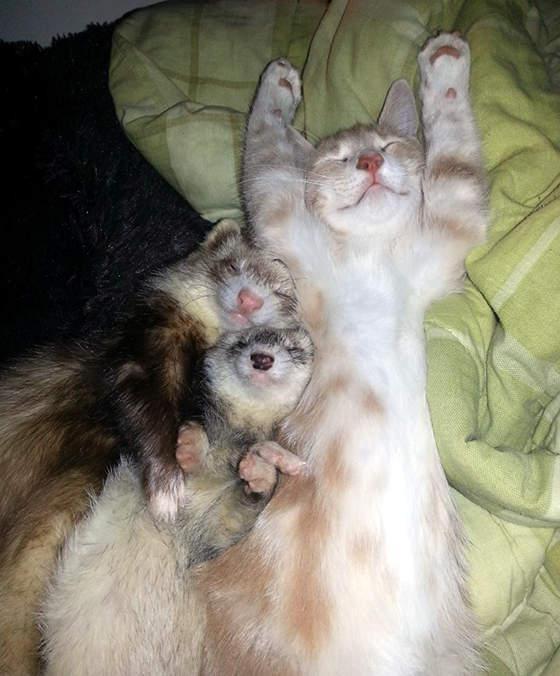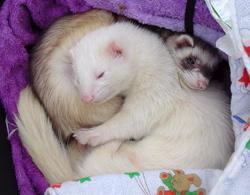The first image is the image on the left, the second image is the image on the right. Evaluate the accuracy of this statement regarding the images: "There are ferrets cuddling with other species of animals.". Is it true? Answer yes or no. Yes. 